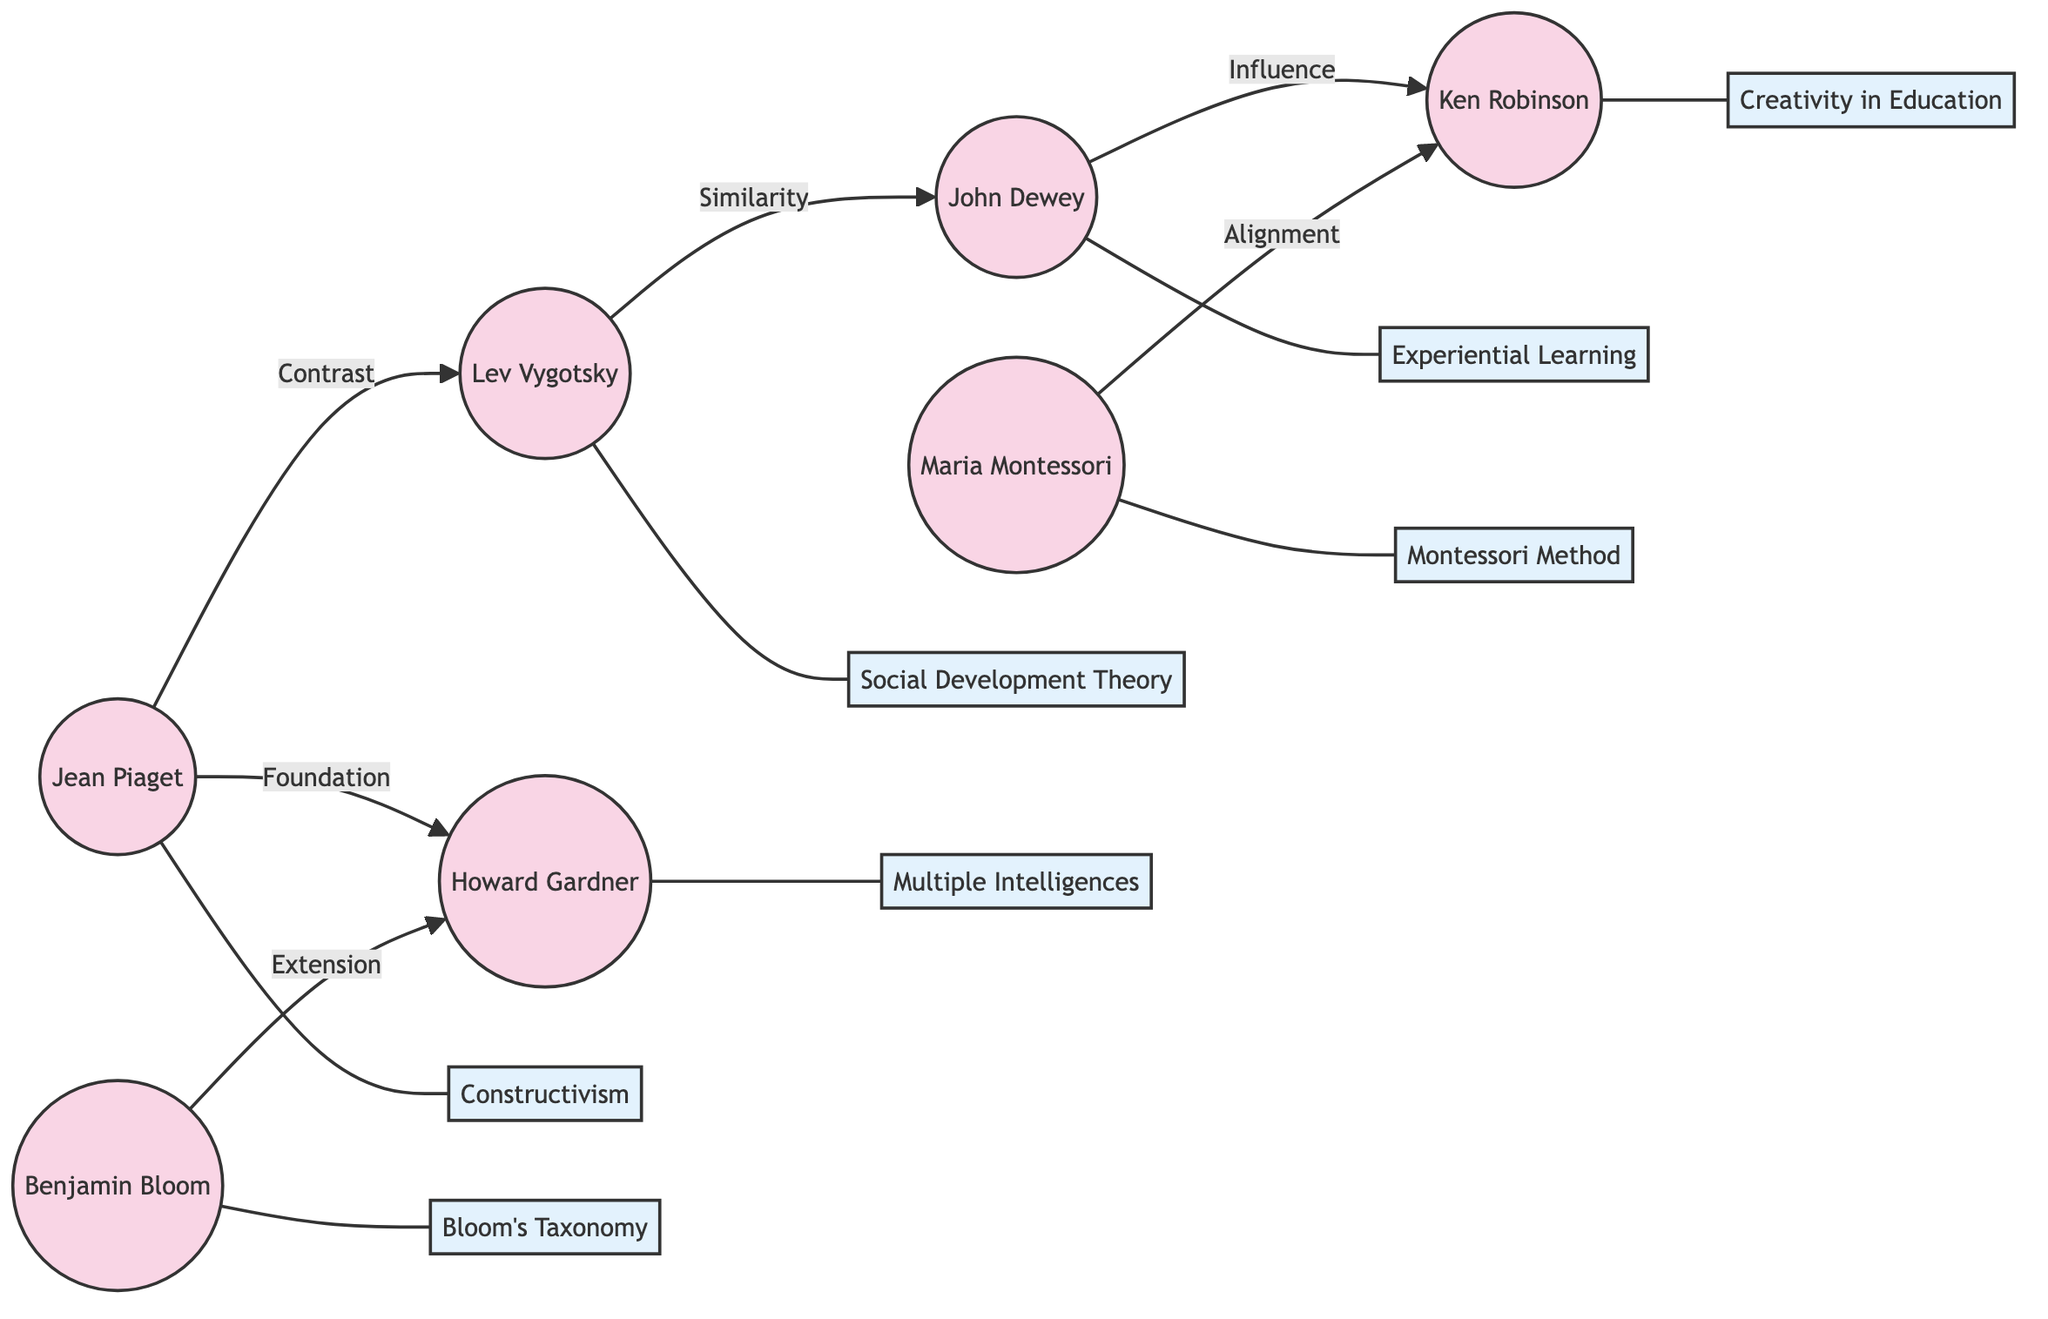What is the concept associated with John Dewey? The diagram indicates that John Dewey is linked to the concept of "Experiential Learning." This direct connection is represented through the node labeled "Experiential Learning."
Answer: Experiential Learning Who does Jean Piaget contrast with? According to the diagram, Jean Piaget has a contrast connection with Lev Vygotsky. This relationship is explicitly labeled as "Contrast" in the diagram's edges.
Answer: Lev Vygotsky How many theorists are shown in the diagram? By counting the nodes specifically marked as theorists, we find there are 7 theorists in total. Each theorist is represented uniquely in the diagram and contributes various concepts.
Answer: 7 What relationship exists between Howard Gardner and Jean Piaget? The diagram indicates that there is a "Foundation" relationship where Jean Piaget provides a foundational concept for Howard Gardner's framework of "Multiple Intelligences."
Answer: Foundation Which theorist's concept is described as "Creativity in Education"? The diagram associates the concept of "Creativity in Education" with Ken Robinson, as per the node that connects this concept to him.
Answer: Ken Robinson What is the relationship labeled between Lev Vygotsky and John Dewey? The relationship labeled between Lev Vygotsky and John Dewey is "Similarity," indicating that their theories share commonalities as depicted in the edge connecting the two.
Answer: Similarity Which two theorists share a connection regarding Montessori Method and modern teaching? According to the diagram, Maria Montessori and Ken Robinson share a connection regarding the "Montessori Method" and its relevance to modern creativity-based teaching, labeled as "Alignment."
Answer: Maria Montessori and Ken Robinson Which theorist extended Bloom's Taxonomy? The edge connecting Bloom and Howard Gardner describes Bloom's Taxonomy as being "Extended" by Howard Gardner's concept of "Multiple Intelligences," thus making Gardner the theorist linked to this extension.
Answer: Howard Gardner What concept does Benjamin Bloom represent? The diagram associates Benjamin Bloom with the concept of "Bloom's Taxonomy," indicating his primary contribution to educational theory as shown in the respective node.
Answer: Bloom's Taxonomy 